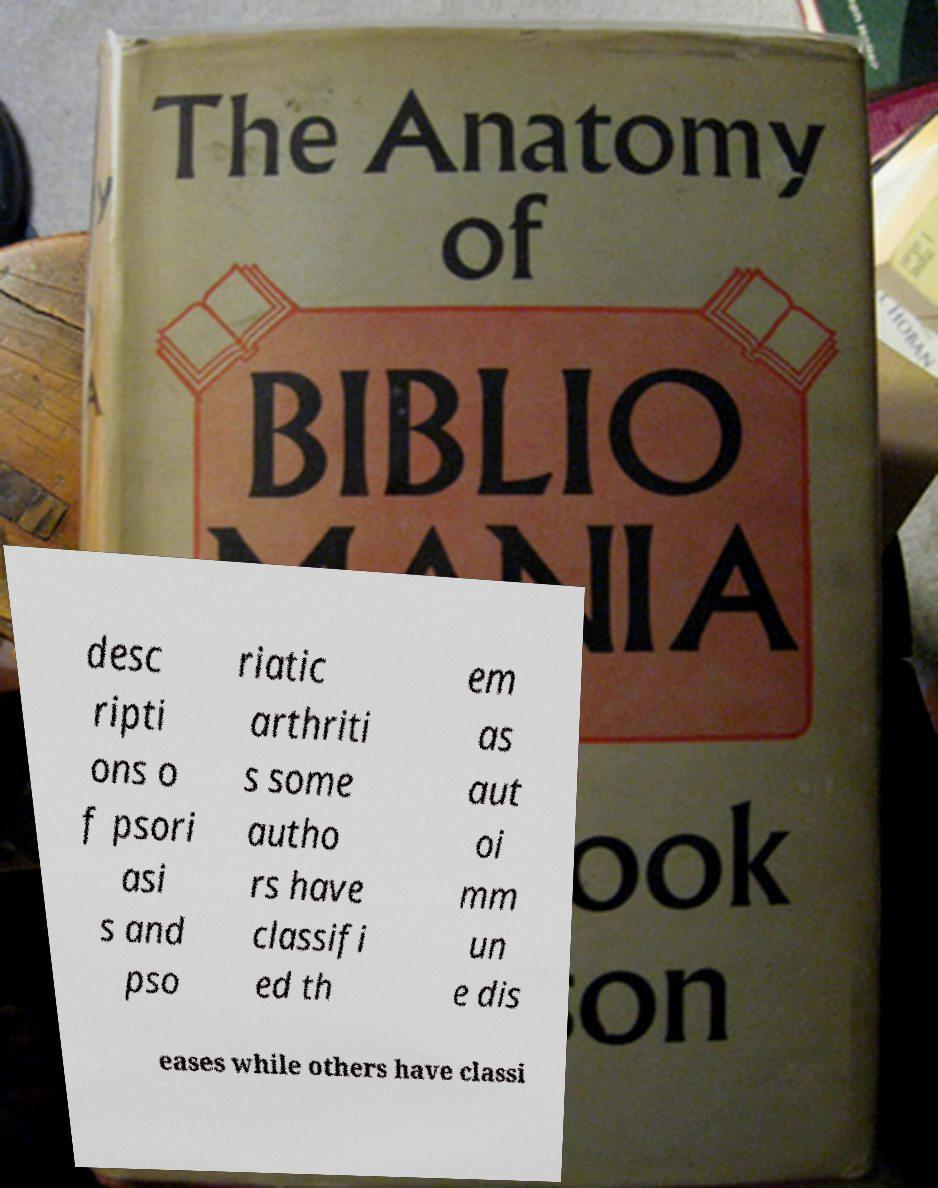Please read and relay the text visible in this image. What does it say? desc ripti ons o f psori asi s and pso riatic arthriti s some autho rs have classifi ed th em as aut oi mm un e dis eases while others have classi 